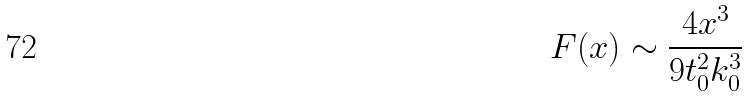Convert formula to latex. <formula><loc_0><loc_0><loc_500><loc_500>F ( x ) \sim \frac { 4 x ^ { 3 } } { 9 t _ { 0 } ^ { 2 } k _ { 0 } ^ { 3 } }</formula> 